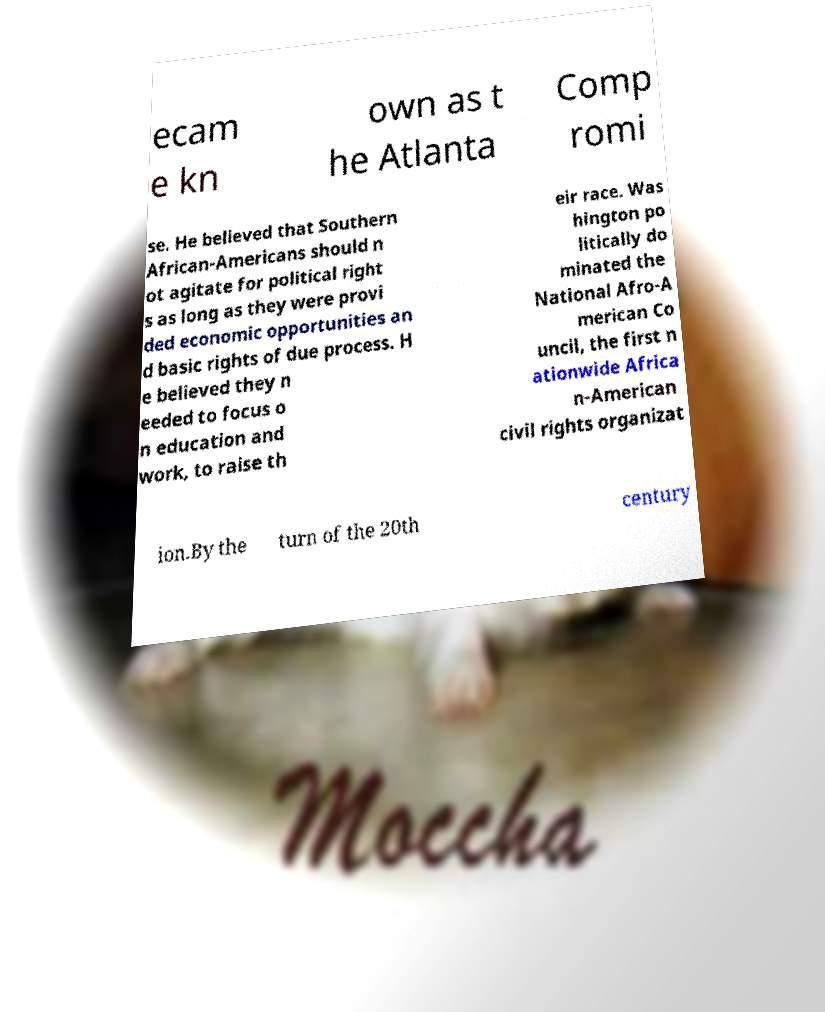Please identify and transcribe the text found in this image. ecam e kn own as t he Atlanta Comp romi se. He believed that Southern African-Americans should n ot agitate for political right s as long as they were provi ded economic opportunities an d basic rights of due process. H e believed they n eeded to focus o n education and work, to raise th eir race. Was hington po litically do minated the National Afro-A merican Co uncil, the first n ationwide Africa n-American civil rights organizat ion.By the turn of the 20th century 